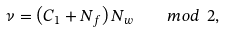Convert formula to latex. <formula><loc_0><loc_0><loc_500><loc_500>\nu = \left ( C _ { 1 } + N _ { f } \right ) N _ { w } \quad m o d \ 2 ,</formula> 